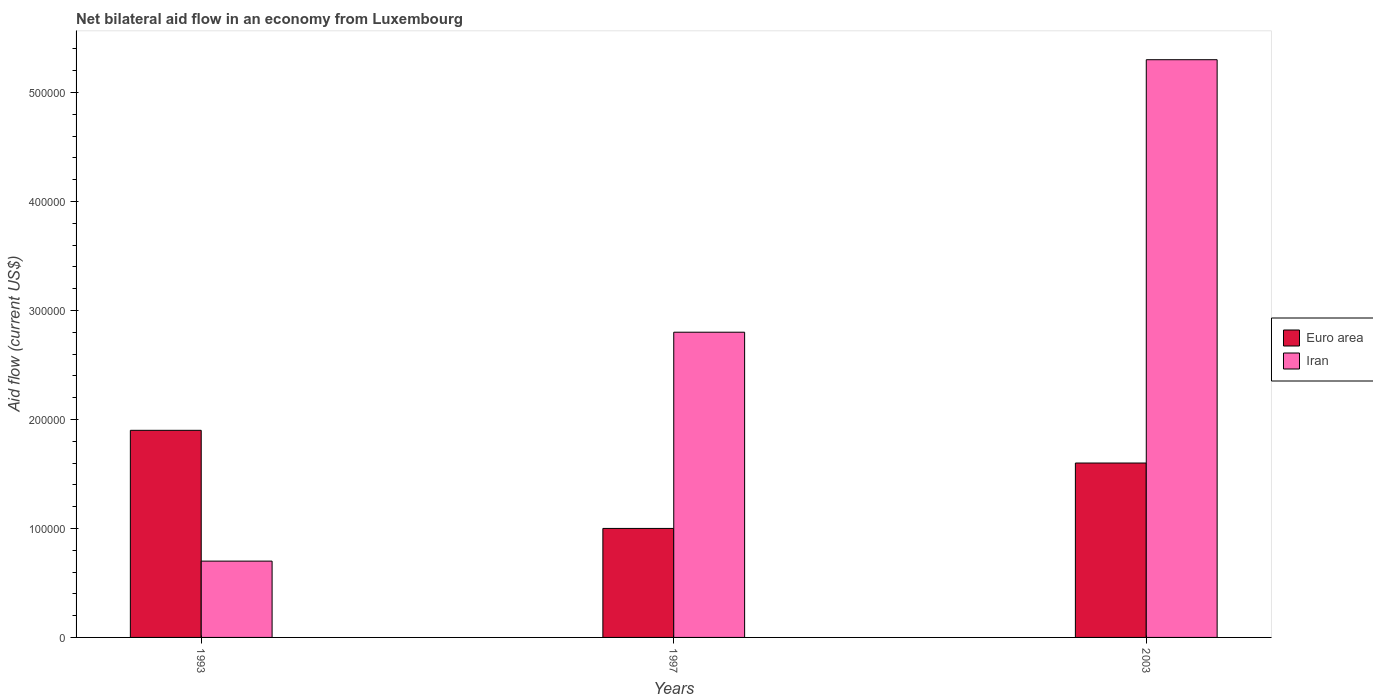How many different coloured bars are there?
Keep it short and to the point. 2. How many groups of bars are there?
Provide a short and direct response. 3. Are the number of bars per tick equal to the number of legend labels?
Give a very brief answer. Yes. How many bars are there on the 3rd tick from the left?
Make the answer very short. 2. In how many cases, is the number of bars for a given year not equal to the number of legend labels?
Provide a short and direct response. 0. What is the net bilateral aid flow in Euro area in 2003?
Your answer should be compact. 1.60e+05. Across all years, what is the maximum net bilateral aid flow in Iran?
Offer a terse response. 5.30e+05. In which year was the net bilateral aid flow in Iran maximum?
Make the answer very short. 2003. In which year was the net bilateral aid flow in Euro area minimum?
Your answer should be compact. 1997. What is the difference between the net bilateral aid flow in Iran in 1993 and the net bilateral aid flow in Euro area in 2003?
Your answer should be very brief. -9.00e+04. What is the average net bilateral aid flow in Euro area per year?
Your answer should be very brief. 1.50e+05. In the year 1993, what is the difference between the net bilateral aid flow in Euro area and net bilateral aid flow in Iran?
Your answer should be very brief. 1.20e+05. What is the ratio of the net bilateral aid flow in Euro area in 1993 to that in 2003?
Provide a succinct answer. 1.19. Is the difference between the net bilateral aid flow in Euro area in 1993 and 2003 greater than the difference between the net bilateral aid flow in Iran in 1993 and 2003?
Your answer should be very brief. Yes. What is the difference between the highest and the lowest net bilateral aid flow in Iran?
Provide a succinct answer. 4.60e+05. In how many years, is the net bilateral aid flow in Iran greater than the average net bilateral aid flow in Iran taken over all years?
Keep it short and to the point. 1. What does the 2nd bar from the left in 1997 represents?
Your answer should be very brief. Iran. What does the 1st bar from the right in 1997 represents?
Offer a terse response. Iran. How many bars are there?
Your answer should be compact. 6. Are the values on the major ticks of Y-axis written in scientific E-notation?
Your response must be concise. No. Does the graph contain any zero values?
Keep it short and to the point. No. Where does the legend appear in the graph?
Make the answer very short. Center right. What is the title of the graph?
Your response must be concise. Net bilateral aid flow in an economy from Luxembourg. Does "Seychelles" appear as one of the legend labels in the graph?
Provide a short and direct response. No. What is the Aid flow (current US$) of Euro area in 1993?
Offer a terse response. 1.90e+05. What is the Aid flow (current US$) of Euro area in 2003?
Your answer should be very brief. 1.60e+05. What is the Aid flow (current US$) in Iran in 2003?
Give a very brief answer. 5.30e+05. Across all years, what is the maximum Aid flow (current US$) of Iran?
Your answer should be very brief. 5.30e+05. Across all years, what is the minimum Aid flow (current US$) of Euro area?
Give a very brief answer. 1.00e+05. Across all years, what is the minimum Aid flow (current US$) of Iran?
Ensure brevity in your answer.  7.00e+04. What is the total Aid flow (current US$) in Euro area in the graph?
Offer a very short reply. 4.50e+05. What is the total Aid flow (current US$) of Iran in the graph?
Keep it short and to the point. 8.80e+05. What is the difference between the Aid flow (current US$) of Euro area in 1993 and that in 1997?
Ensure brevity in your answer.  9.00e+04. What is the difference between the Aid flow (current US$) in Iran in 1993 and that in 1997?
Provide a short and direct response. -2.10e+05. What is the difference between the Aid flow (current US$) of Iran in 1993 and that in 2003?
Your answer should be very brief. -4.60e+05. What is the difference between the Aid flow (current US$) in Iran in 1997 and that in 2003?
Your response must be concise. -2.50e+05. What is the difference between the Aid flow (current US$) in Euro area in 1993 and the Aid flow (current US$) in Iran in 1997?
Ensure brevity in your answer.  -9.00e+04. What is the difference between the Aid flow (current US$) in Euro area in 1997 and the Aid flow (current US$) in Iran in 2003?
Offer a terse response. -4.30e+05. What is the average Aid flow (current US$) of Euro area per year?
Provide a succinct answer. 1.50e+05. What is the average Aid flow (current US$) in Iran per year?
Ensure brevity in your answer.  2.93e+05. In the year 1993, what is the difference between the Aid flow (current US$) in Euro area and Aid flow (current US$) in Iran?
Offer a terse response. 1.20e+05. In the year 1997, what is the difference between the Aid flow (current US$) of Euro area and Aid flow (current US$) of Iran?
Offer a very short reply. -1.80e+05. In the year 2003, what is the difference between the Aid flow (current US$) in Euro area and Aid flow (current US$) in Iran?
Give a very brief answer. -3.70e+05. What is the ratio of the Aid flow (current US$) of Euro area in 1993 to that in 2003?
Make the answer very short. 1.19. What is the ratio of the Aid flow (current US$) of Iran in 1993 to that in 2003?
Make the answer very short. 0.13. What is the ratio of the Aid flow (current US$) in Euro area in 1997 to that in 2003?
Offer a terse response. 0.62. What is the ratio of the Aid flow (current US$) in Iran in 1997 to that in 2003?
Keep it short and to the point. 0.53. What is the difference between the highest and the lowest Aid flow (current US$) of Euro area?
Ensure brevity in your answer.  9.00e+04. What is the difference between the highest and the lowest Aid flow (current US$) of Iran?
Your answer should be compact. 4.60e+05. 